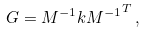<formula> <loc_0><loc_0><loc_500><loc_500>G = M ^ { - 1 } k { M ^ { - 1 } } ^ { T } \, ,</formula> 